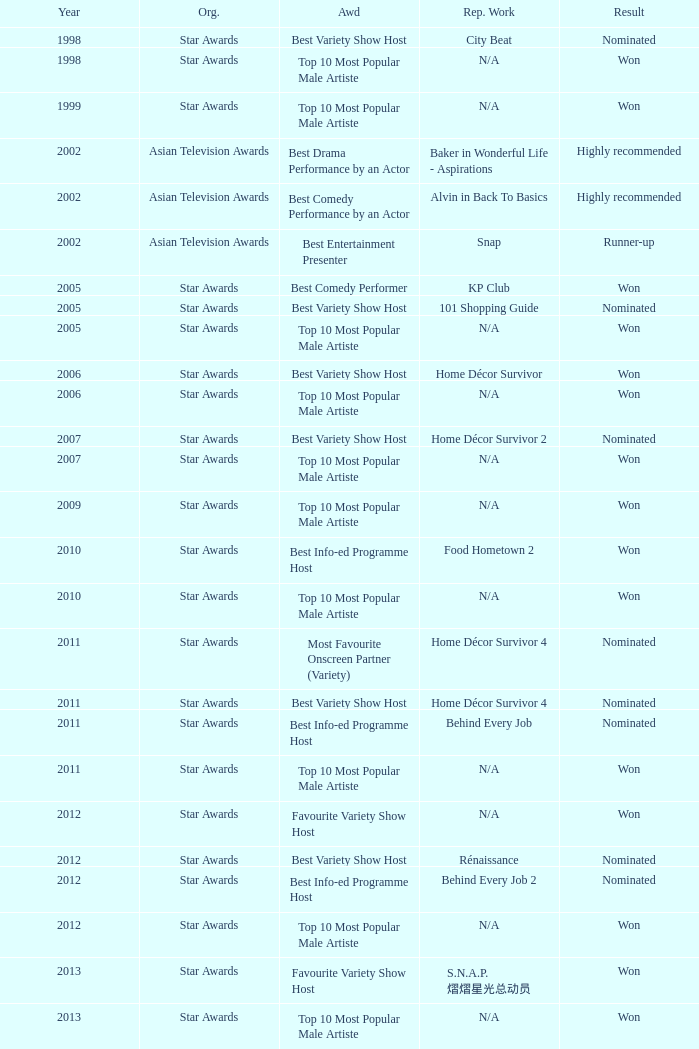What is the award for 1998 with Representative Work of city beat? Best Variety Show Host. 